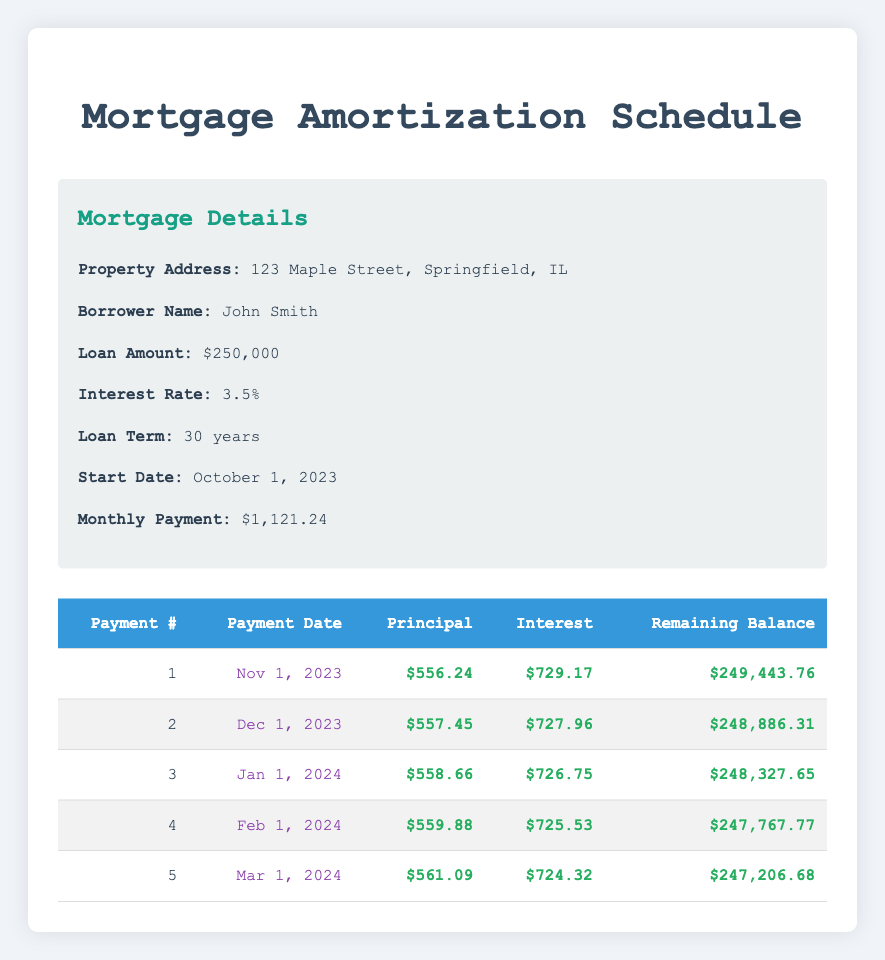What is the amount of the first principal payment? The first principal payment is explicitly listed in the table under the "Principal" column for the first payment number. It states $556.24.
Answer: 556.24 What is the total interest paid in the first three months? To find the total interest for the first three months, we need to sum the interest payments for each of the first three entries in the "Interest" column: $729.17 (first) + $727.96 (second) + $726.75 (third) = $2,183.88.
Answer: 2183.88 Is the principal payment increasing or decreasing over the first five payments? Observing the "Principal" column, each subsequent principal payment (556.24, 557.45, 558.66, 559.88, 561.09) increases from the previous one. This indicates a trend of increasing principal payments.
Answer: Yes What is the remaining balance after the 5th payment? The remaining balance after the fifth payment is stated directly in the table under the "Remaining Balance" column for payment number 5, which is $247,206.68.
Answer: 247206.68 How much interest was paid in the 4th month compared to the principal payment of that month? In the 4th month, the interest payment is $725.53, and the principal payment is $559.88. Thus, comparing the two shows that the interest was higher than the principal payment. This can be concluded by looking at the respective columns for the 4th payment.
Answer: Interest is higher What is the average monthly principal payment for the first five months? To calculate the average monthly principal payment for the first five months, sum the principal payments: $556.24 + $557.45 + $558.66 + $559.88 + $561.09 = $2,893.32. Then divide by 5: $2,893.32 / 5 = $578.66.
Answer: 578.66 How does the interest payment change from the first to the second month? The interest payment decreased from the first month ($729.17) to the second month ($727.96). To find the change, we subtract: $729.17 - $727.96 = $1.21. This indicates that the interest payment is slightly lower in the second month.
Answer: Decreased by 1.21 What is the total remaining balance after the first two payments? The remaining balance after the second payment is provided in the table as $248,886.31. To find out the total remaining balance after the first two payments, that value is directly taken from the table without any calculation needed.
Answer: 248886.31 What is the amount of principal paid in the third month? The amount of principal paid in the third month is stated in the table under the "Principal" column for the third payment number. It indicates $558.66.
Answer: 558.66 